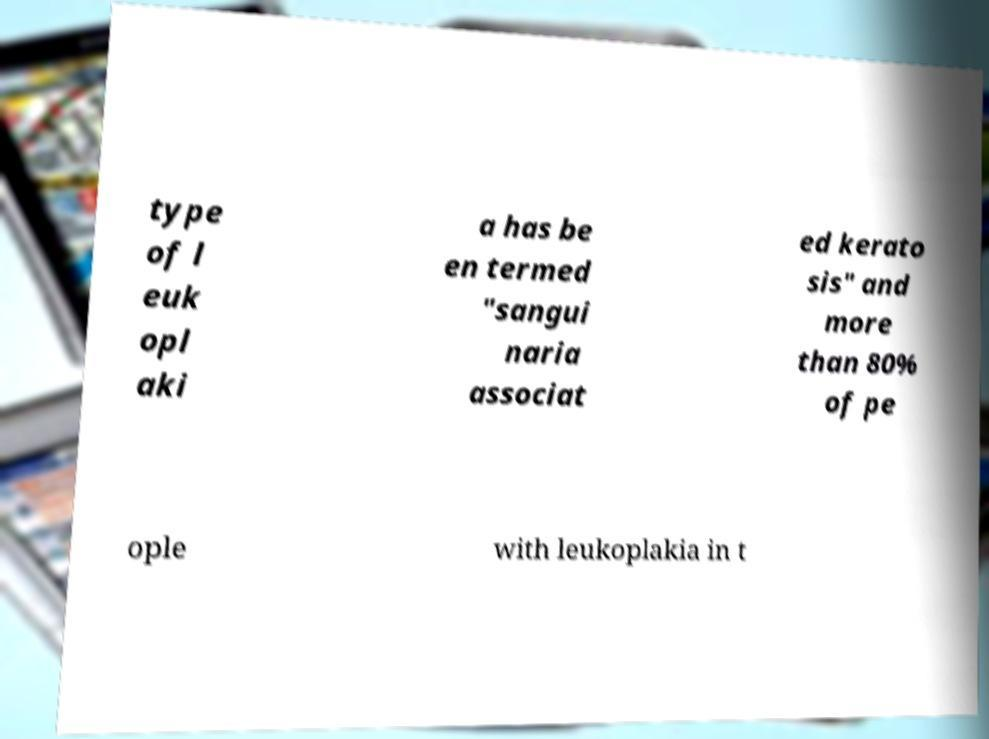There's text embedded in this image that I need extracted. Can you transcribe it verbatim? type of l euk opl aki a has be en termed "sangui naria associat ed kerato sis" and more than 80% of pe ople with leukoplakia in t 